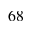Convert formula to latex. <formula><loc_0><loc_0><loc_500><loc_500>^ { 6 8 }</formula> 